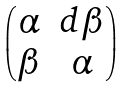Convert formula to latex. <formula><loc_0><loc_0><loc_500><loc_500>\begin{pmatrix} \alpha & d \beta \\ \beta & \alpha \end{pmatrix}</formula> 